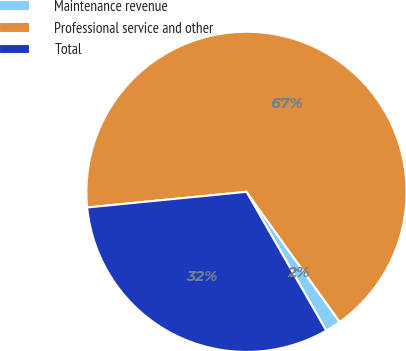Convert chart to OTSL. <chart><loc_0><loc_0><loc_500><loc_500><pie_chart><fcel>Maintenance revenue<fcel>Professional service and other<fcel>Total<nl><fcel>1.59%<fcel>66.67%<fcel>31.75%<nl></chart> 